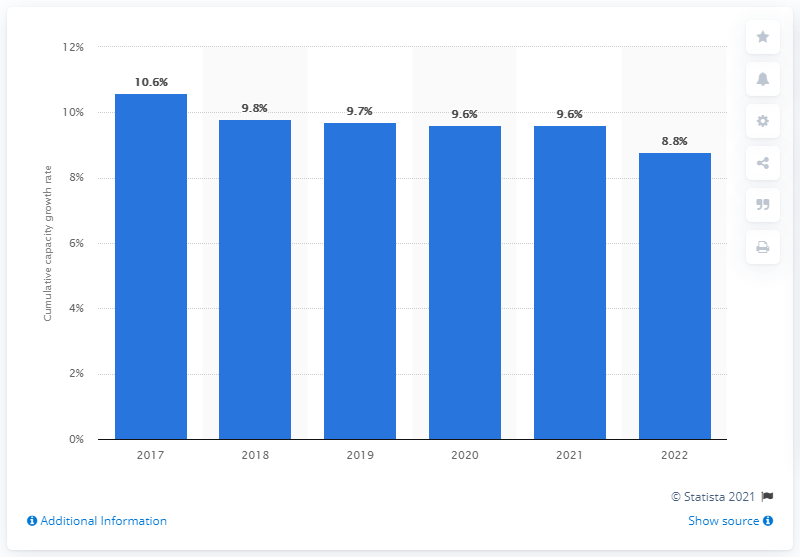Give some essential details in this illustration. The projected growth rate of wind power capacity in 2022 is expected to be 8.8%. 